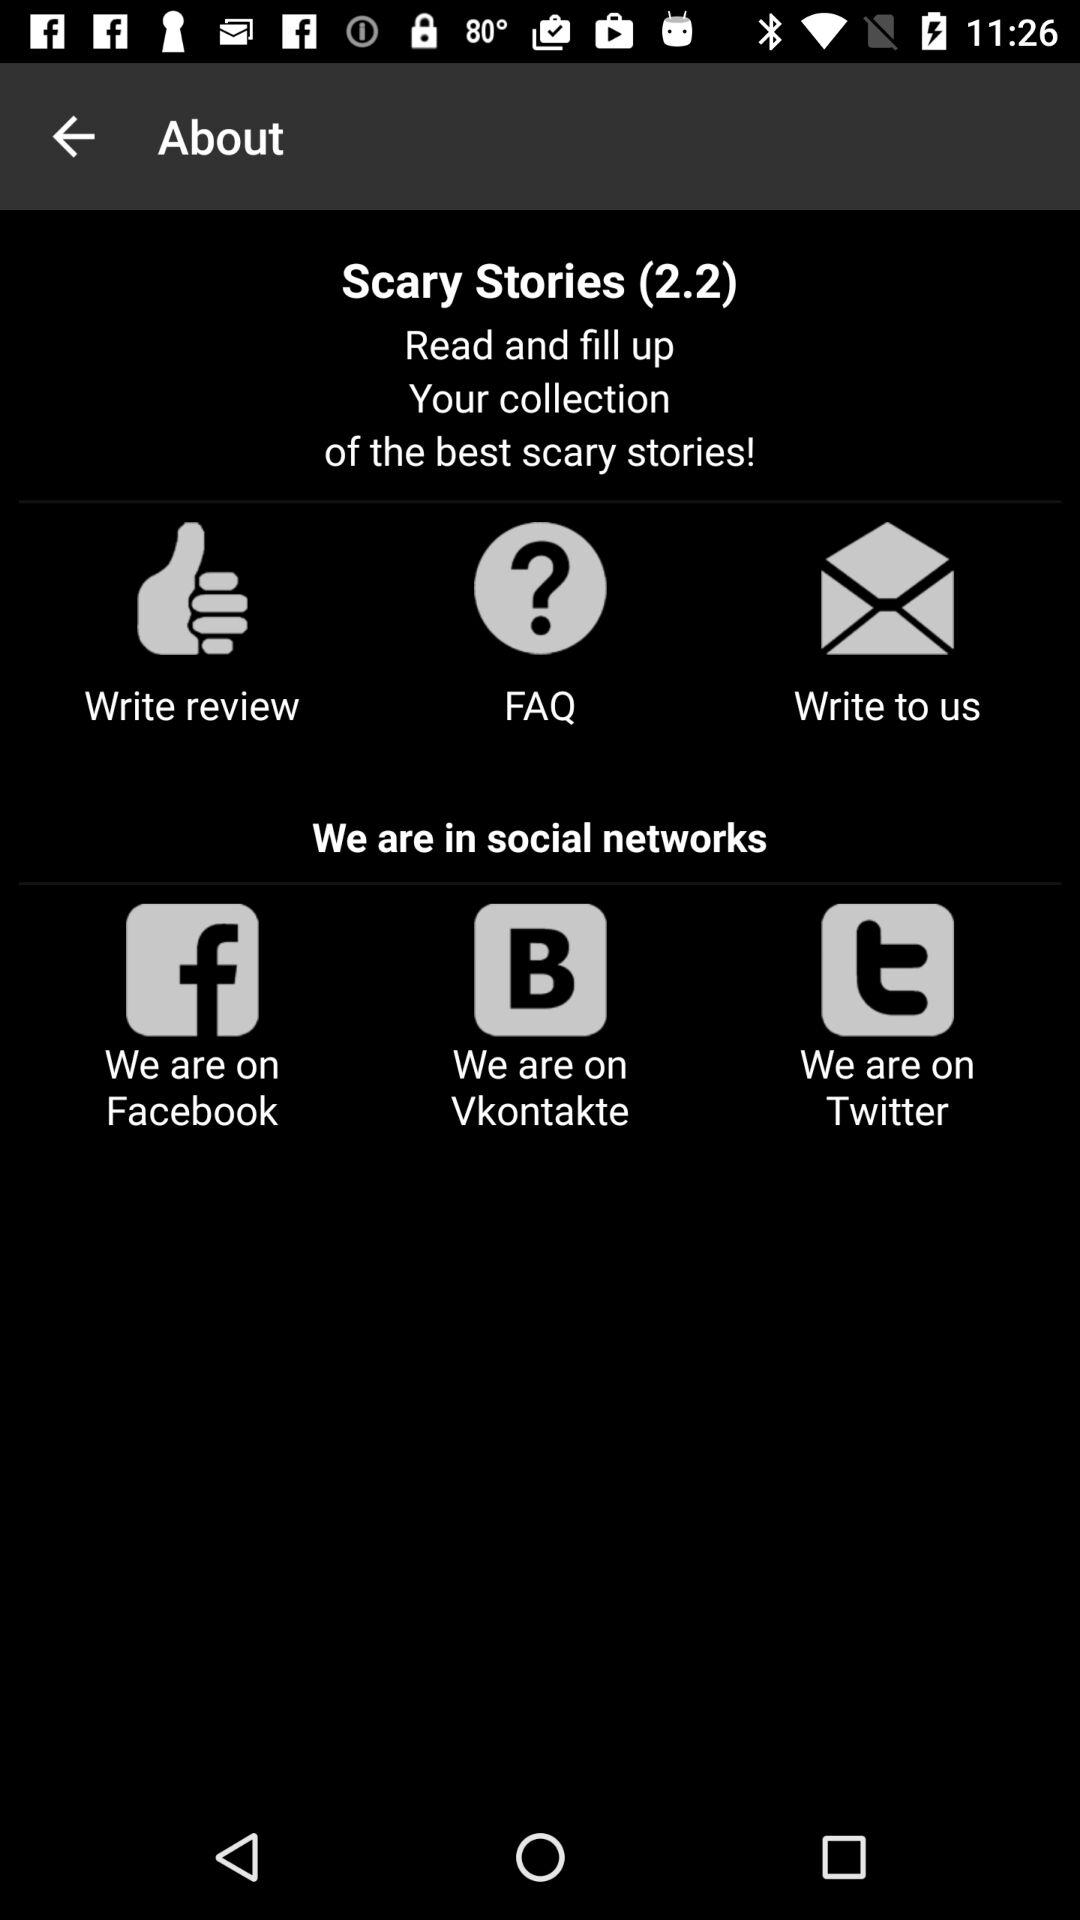What is the version of the Scary Stories application? The version of the Scary Stories application is 2.2. 